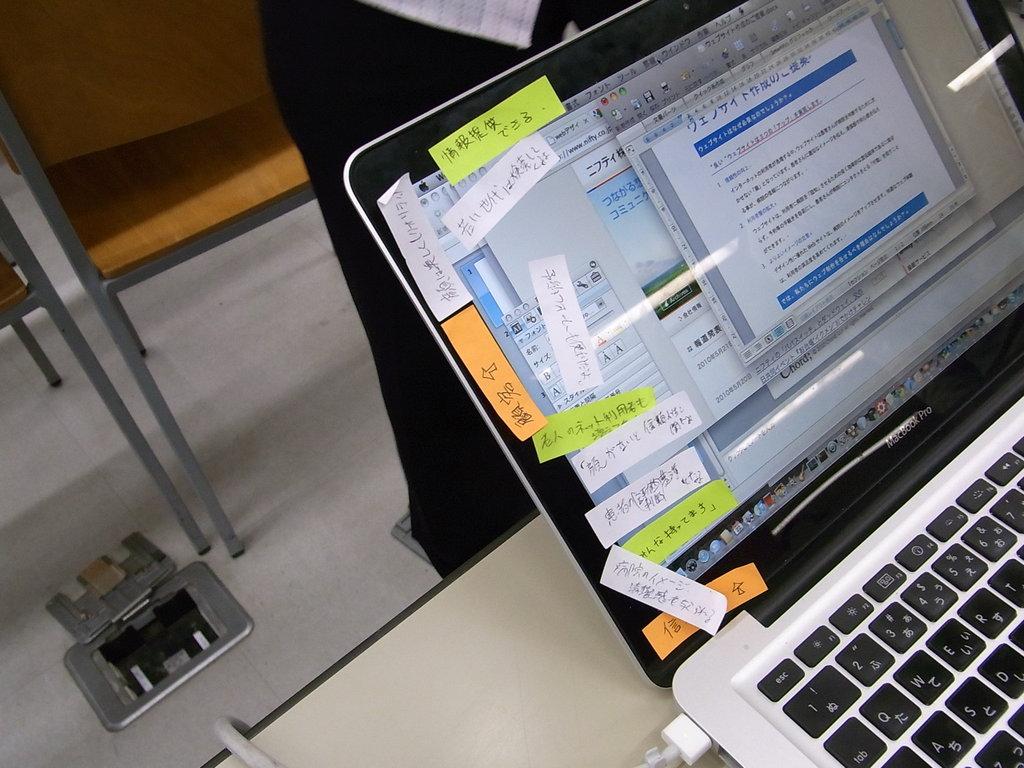All foreign language?
Keep it short and to the point. Yes. 